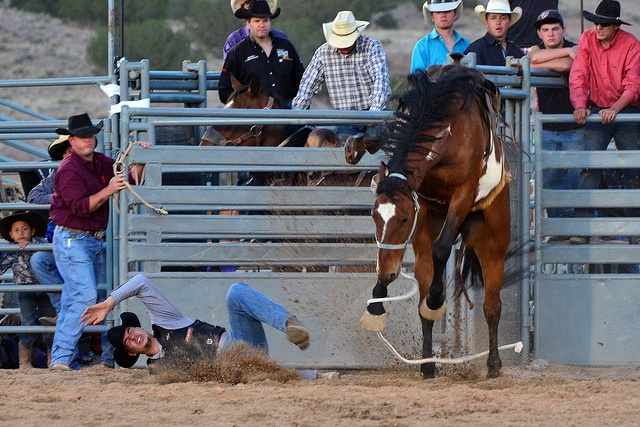Describe the objects in this image and their specific colors. I can see horse in black, maroon, and gray tones, people in black and gray tones, people in black, darkgray, purple, and gray tones, people in black, salmon, and brown tones, and people in black, darkgray, lightgray, and gray tones in this image. 